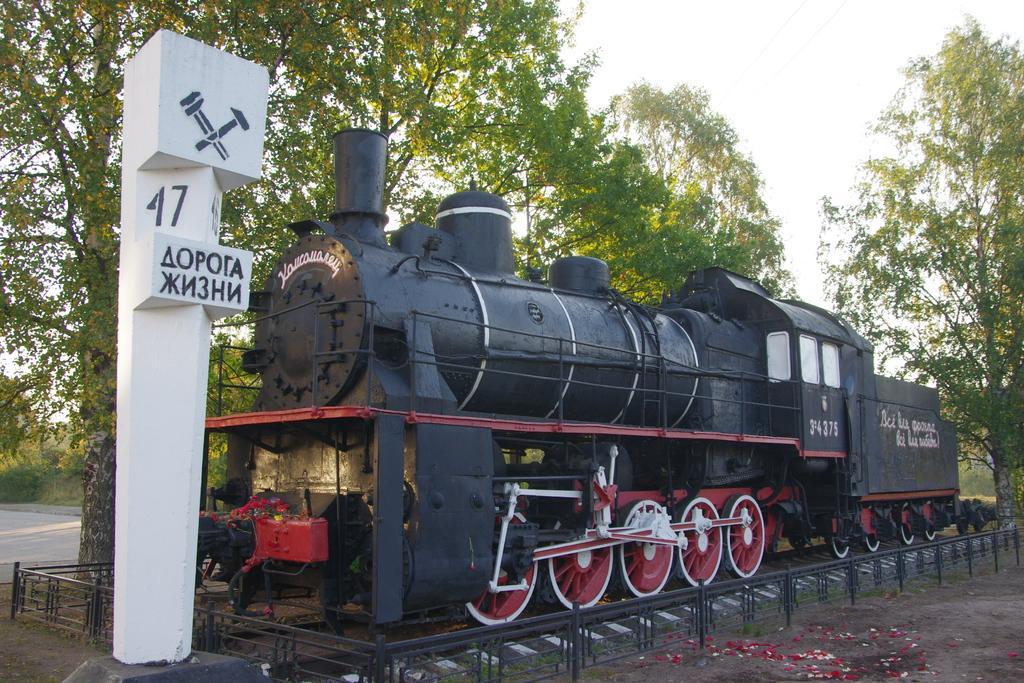What is the main subject of the image? The main subject of the image is a railway engine. Where is the railway engine located in the image? The railway engine is in the center of the image. What is the railway engine positioned on? The railway engine is on a railway track. What can be seen in the background of the image? There are trees, a road, and the sky visible in the background of the image. How many sheep are visible in the image? There are no sheep present in the image. What type of engine is powering the railway engine in the image? The image does not show any other engines powering the railway engine; it is a standalone railway engine. 